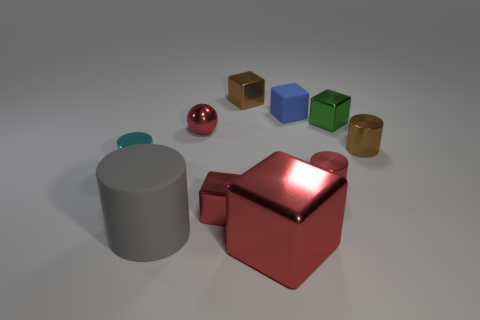What number of metallic things are either big cylinders or cylinders?
Your response must be concise. 3. What is the material of the tiny brown object that is on the left side of the tiny red cylinder?
Provide a short and direct response. Metal. How many things are tiny matte objects or metal cylinders that are in front of the cyan metallic cylinder?
Keep it short and to the point. 2. There is a cyan object that is the same size as the red shiny ball; what shape is it?
Your response must be concise. Cylinder. How many other balls have the same color as the small sphere?
Provide a succinct answer. 0. Are the cylinder on the right side of the green block and the large gray object made of the same material?
Provide a succinct answer. No. What is the shape of the cyan thing?
Offer a terse response. Cylinder. How many gray objects are tiny metallic things or big metallic spheres?
Your answer should be compact. 0. How many other objects are the same material as the small green block?
Offer a very short reply. 7. Do the large thing that is on the left side of the large red metal object and the tiny cyan metallic thing have the same shape?
Keep it short and to the point. Yes. 